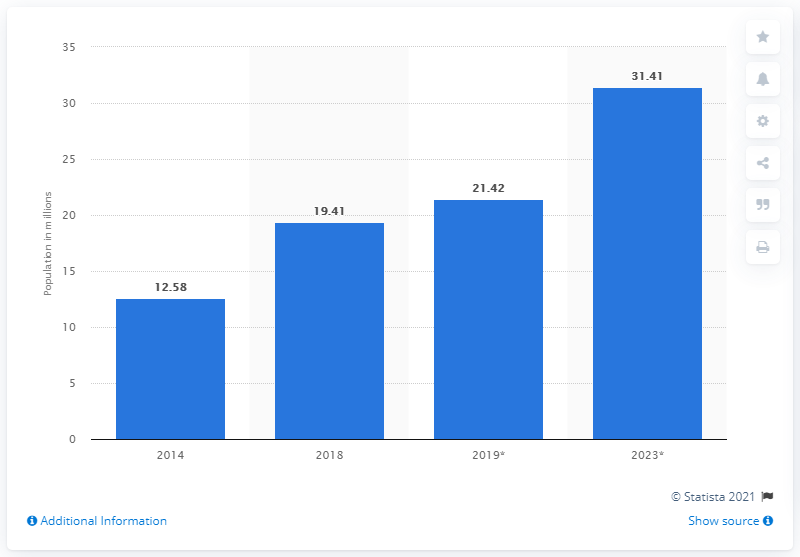Give some essential details in this illustration. In 2018, the population of pet dogs in India was approximately 19.41 million. 